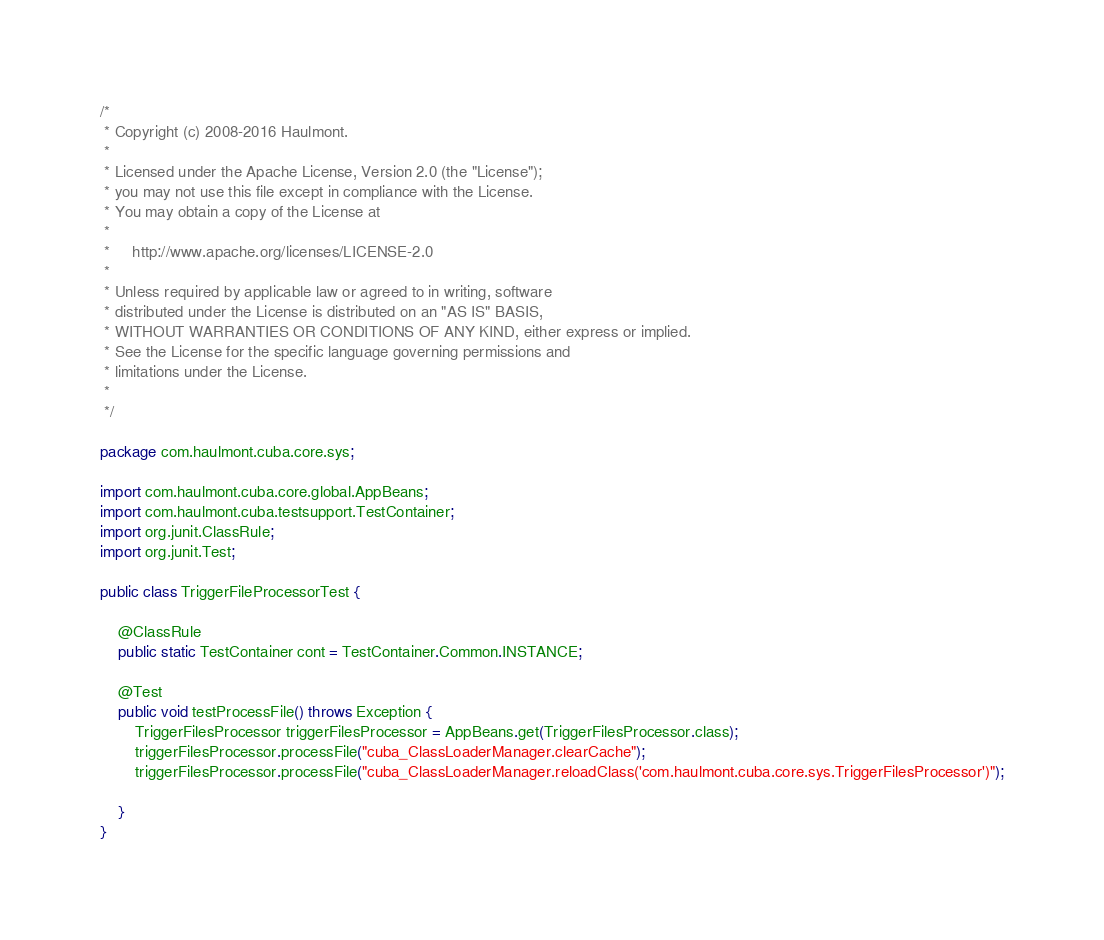<code> <loc_0><loc_0><loc_500><loc_500><_Java_>/*
 * Copyright (c) 2008-2016 Haulmont.
 *
 * Licensed under the Apache License, Version 2.0 (the "License");
 * you may not use this file except in compliance with the License.
 * You may obtain a copy of the License at
 *
 *     http://www.apache.org/licenses/LICENSE-2.0
 *
 * Unless required by applicable law or agreed to in writing, software
 * distributed under the License is distributed on an "AS IS" BASIS,
 * WITHOUT WARRANTIES OR CONDITIONS OF ANY KIND, either express or implied.
 * See the License for the specific language governing permissions and
 * limitations under the License.
 *
 */

package com.haulmont.cuba.core.sys;

import com.haulmont.cuba.core.global.AppBeans;
import com.haulmont.cuba.testsupport.TestContainer;
import org.junit.ClassRule;
import org.junit.Test;

public class TriggerFileProcessorTest {

    @ClassRule
    public static TestContainer cont = TestContainer.Common.INSTANCE;

    @Test
    public void testProcessFile() throws Exception {
        TriggerFilesProcessor triggerFilesProcessor = AppBeans.get(TriggerFilesProcessor.class);
        triggerFilesProcessor.processFile("cuba_ClassLoaderManager.clearCache");
        triggerFilesProcessor.processFile("cuba_ClassLoaderManager.reloadClass('com.haulmont.cuba.core.sys.TriggerFilesProcessor')");

    }
}</code> 